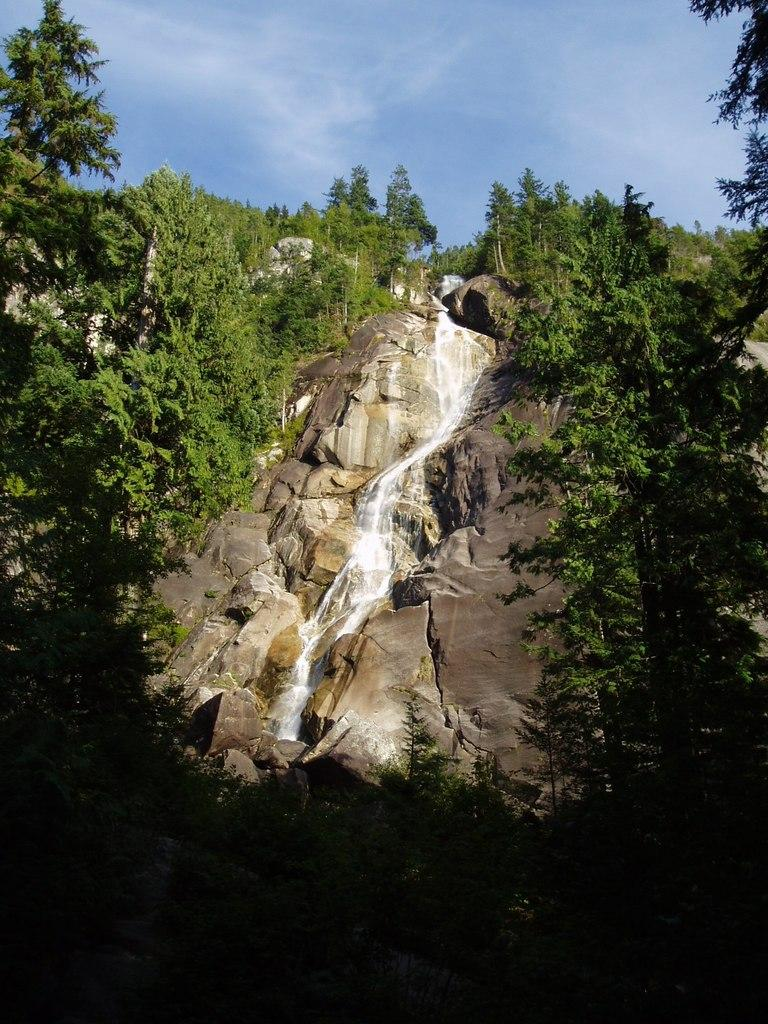What natural feature is the main subject of the image? There is a waterfall in the image. What type of vegetation surrounds the waterfall? There are trees and plants on both sides of the waterfall. What type of terrain is visible near the waterfall? There are stones on both sides of the waterfall. What is visible at the top of the image? The sky is visible at the top of the image. What can be seen in the sky? Clouds are present in the sky. What country is the waterfall located in, according to the image? The image does not provide information about the country where the waterfall is located. What does the land look like around the waterfall in the image? The image does not provide a detailed description of the land around the waterfall, only mentioning the presence of stones, trees, and plants. 